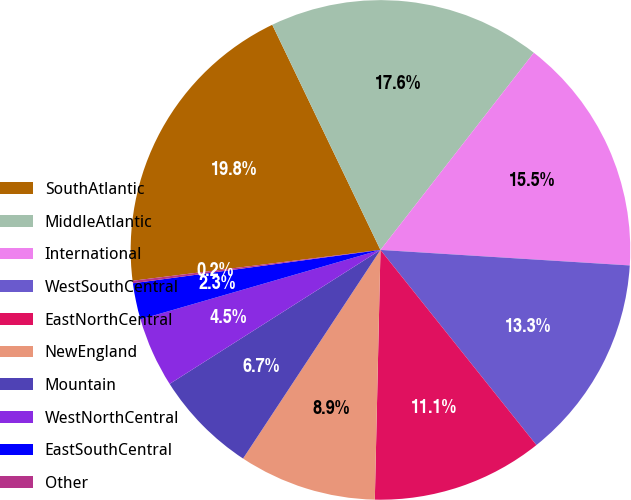<chart> <loc_0><loc_0><loc_500><loc_500><pie_chart><fcel>SouthAtlantic<fcel>MiddleAtlantic<fcel>International<fcel>WestSouthCentral<fcel>EastNorthCentral<fcel>NewEngland<fcel>Mountain<fcel>WestNorthCentral<fcel>EastSouthCentral<fcel>Other<nl><fcel>19.84%<fcel>17.65%<fcel>15.47%<fcel>13.28%<fcel>11.09%<fcel>8.91%<fcel>6.72%<fcel>4.53%<fcel>2.35%<fcel>0.16%<nl></chart> 